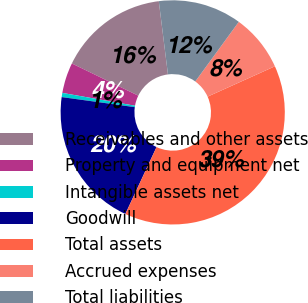Convert chart to OTSL. <chart><loc_0><loc_0><loc_500><loc_500><pie_chart><fcel>Receivables and other assets<fcel>Property and equipment net<fcel>Intangible assets net<fcel>Goodwill<fcel>Total assets<fcel>Accrued expenses<fcel>Total liabilities<nl><fcel>15.83%<fcel>4.41%<fcel>0.6%<fcel>20.24%<fcel>38.69%<fcel>8.22%<fcel>12.02%<nl></chart> 